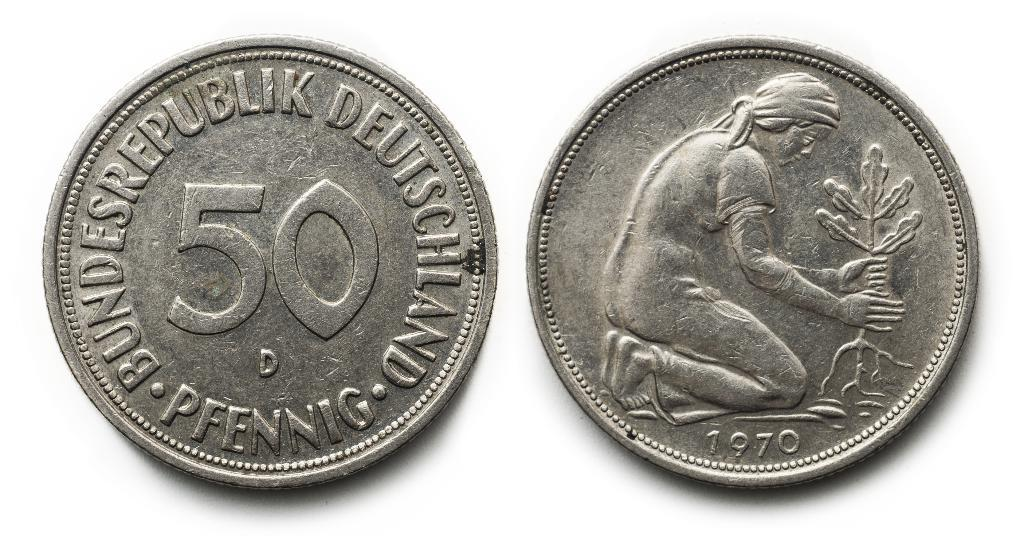<image>
Present a compact description of the photo's key features. Two 50 pfennig coins are shown side by side. 